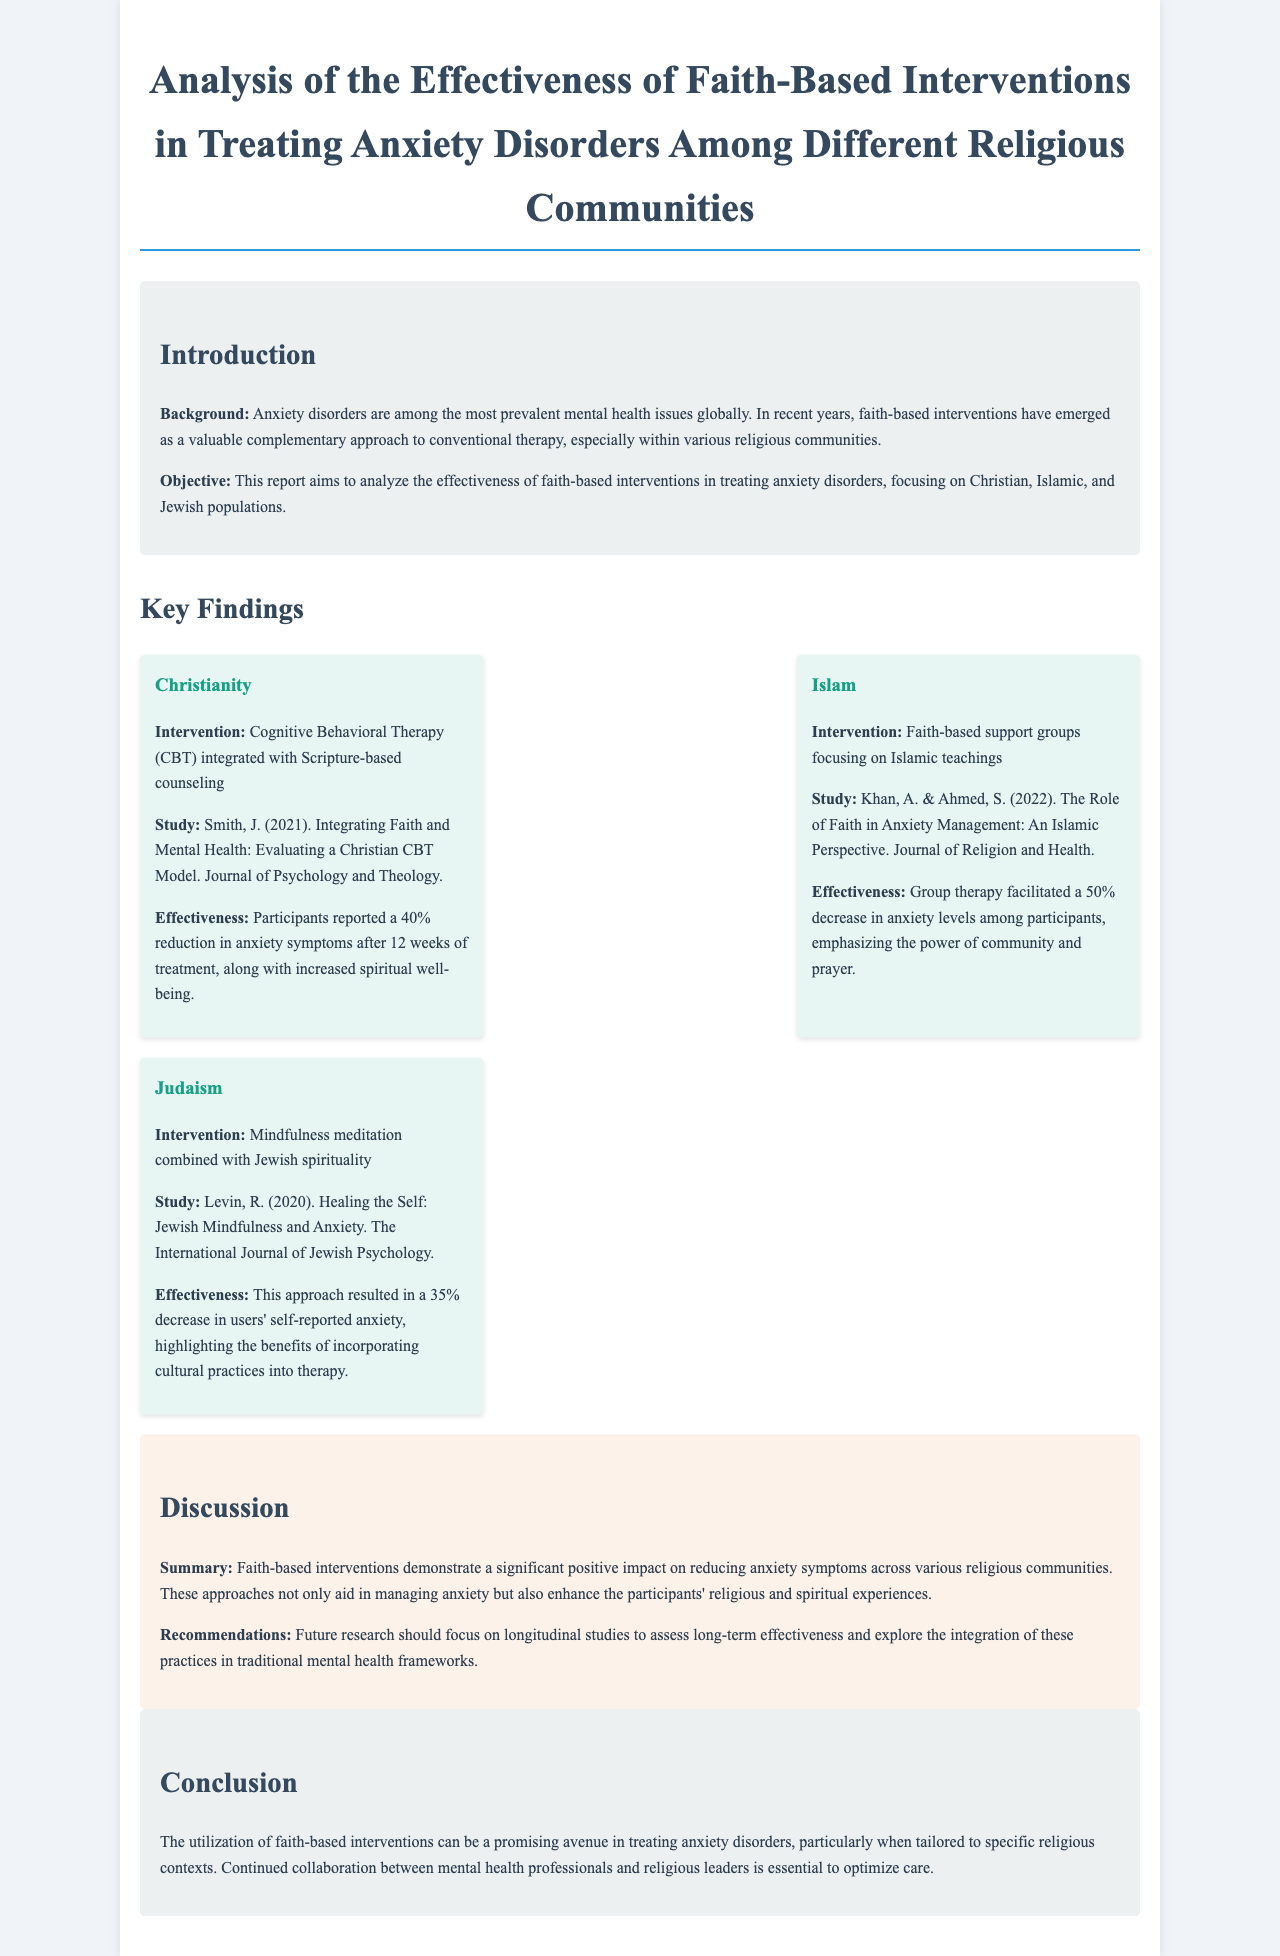What is the title of the report? The title provides a clear identification of the focus of the report, which is on faith-based interventions for treating anxiety.
Answer: Analysis of the Effectiveness of Faith-Based Interventions in Treating Anxiety Disorders Among Different Religious Communities Who conducted the study on Christians? The study references a specific individual whose work contributed to understanding the integration of faith and mental health.
Answer: Smith, J What was the reported percentage decrease in anxiety symptoms for Islamic interventions? This figure illustrates the effectiveness of the interventions within the Islamic community as documented.
Answer: 50% Which therapeutic approach is used in the Jewish community intervention? The approach mentioned blends mindfulness with cultural spirituality to address anxiety.
Answer: Mindfulness meditation combined with Jewish spirituality What is the main objective of the report? The objective summarizes the main goal that the authors aimed to achieve through their analysis of interventions.
Answer: To analyze the effectiveness of faith-based interventions in treating anxiety disorders What practice is emphasized in the Islamic faith-based support groups? The practice highlights a common element found within Islamic traditions that is acknowledged in the study.
Answer: Prayer What was the reduction in anxiety symptoms reported for Christian participants? This statistic shows the impact of the integrated intervention specific to the Christian community.
Answer: 40% reduction What future research is recommended in the document? This recommendation indicates the direction future studies should take to better understand the current findings.
Answer: Longitudinal studies to assess long-term effectiveness 